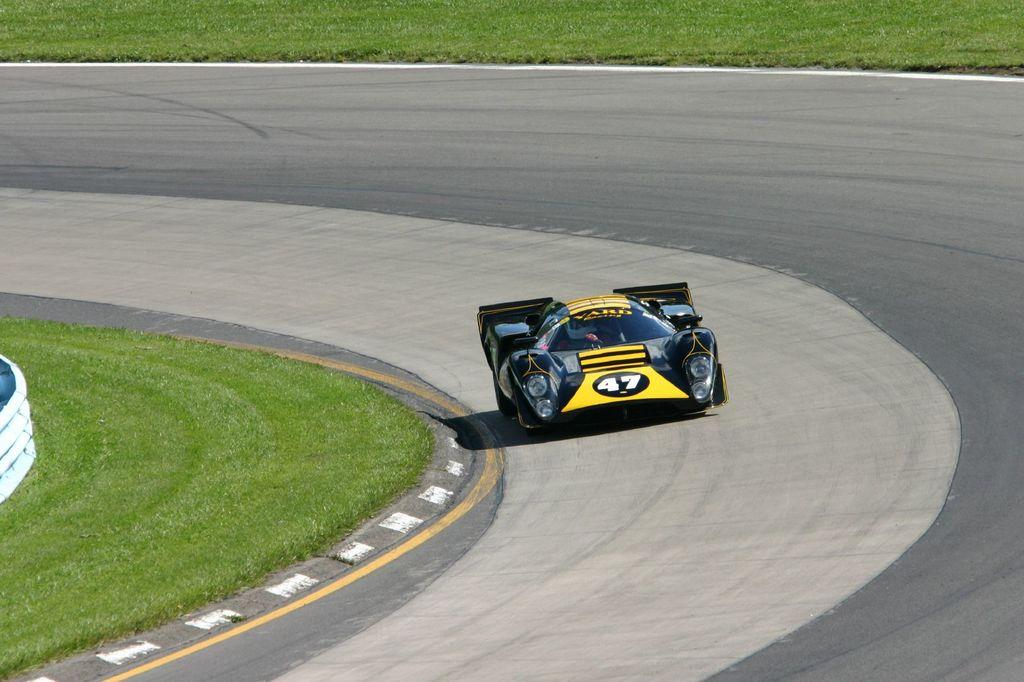What is the main subject of the image? The main subject of the image is a racing car. Where is the racing car located in the image? The racing car is on the road in the image. What can be seen in the background of the image? The road is visible in the image. What type of vegetation is present in the image? There is grass in the image. What type of leather is used to make the racing car's seat in the image? There is no information about the racing car's seat or the type of leather used in the image. 